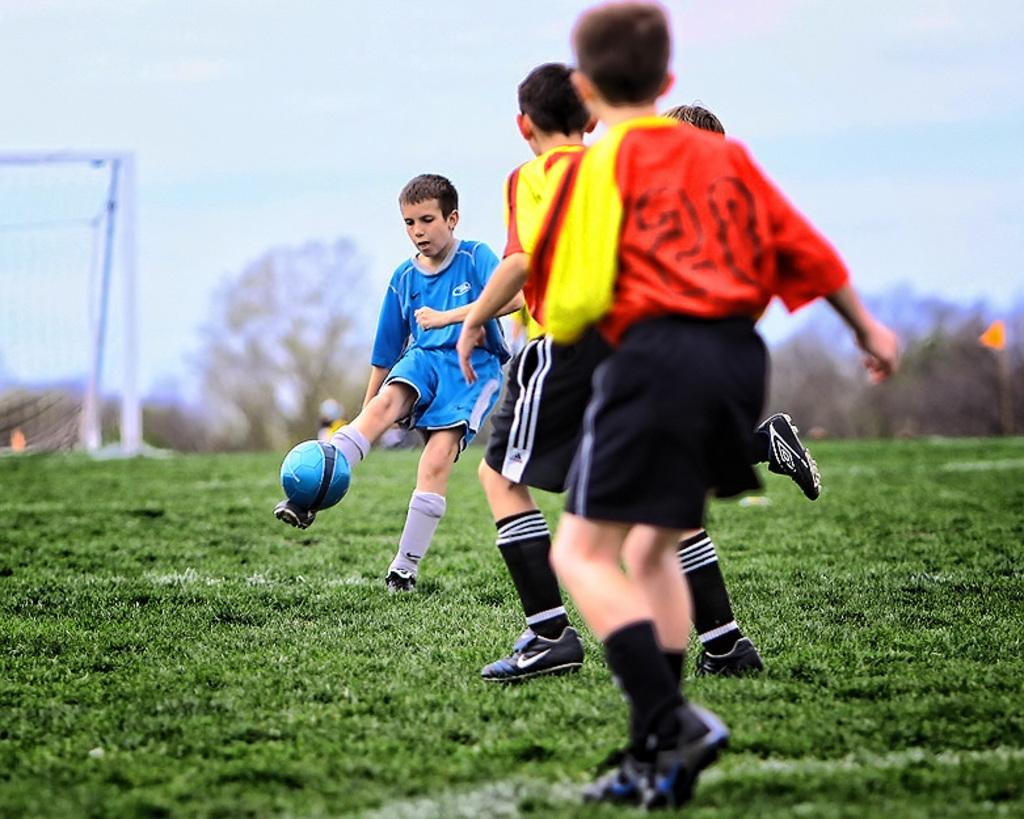What activity are the persons in the image engaged in? The persons in the image are playing football. What is the surface they are playing on? The playing surface is grass. What structure can be seen in the image, which is likely related to the game? There is a mesh in the image, likely referring to a goal. What can be seen in the background of the image? There are trees and the sky visible in the background of the image. What type of wren can be seen flying over the football players in the image? There is no wren present in the image; it is focused on the football players and the surrounding environment. 